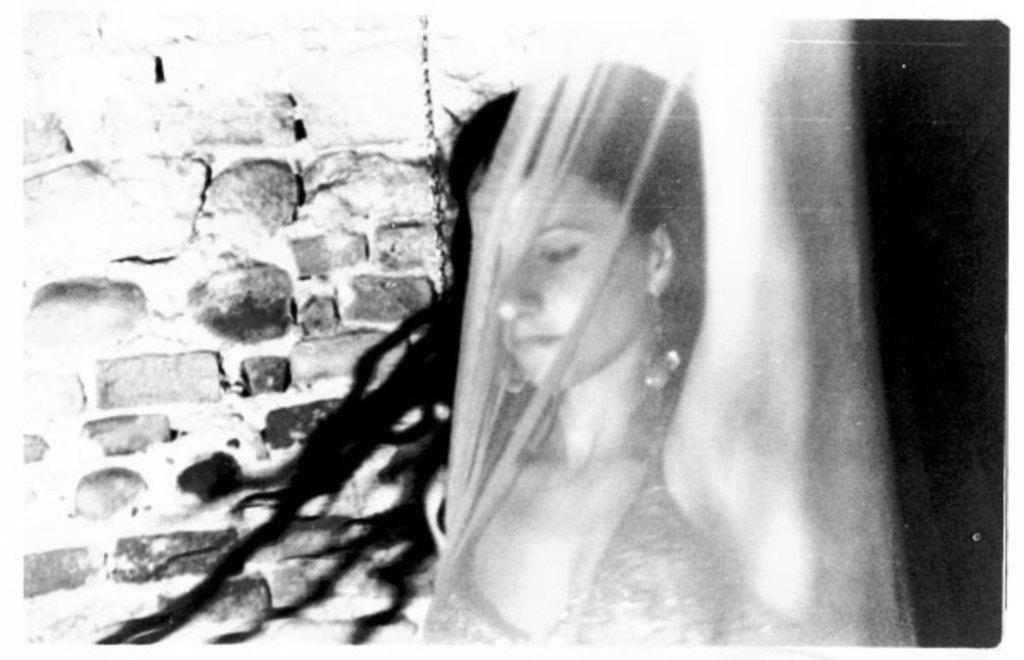How would you summarize this image in a sentence or two? This is the black and white image where we can see a woman behind the cover. In the background, we can see the stone wall and this part of the image is dark. 